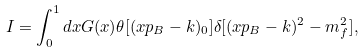Convert formula to latex. <formula><loc_0><loc_0><loc_500><loc_500>I = \int _ { 0 } ^ { 1 } d x G ( x ) \theta [ ( x p _ { B } - k ) _ { 0 } ] \delta [ ( x p _ { B } - k ) ^ { 2 } - m _ { f } ^ { 2 } ] ,</formula> 